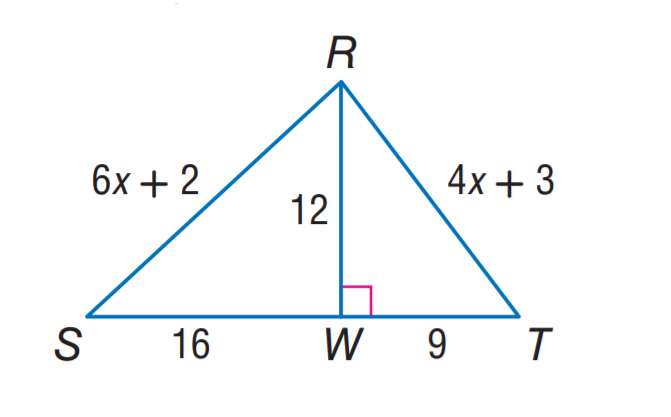Answer the mathemtical geometry problem and directly provide the correct option letter.
Question: Find R T.
Choices: A: 12 B: 15 C: 16 D: 20 B 